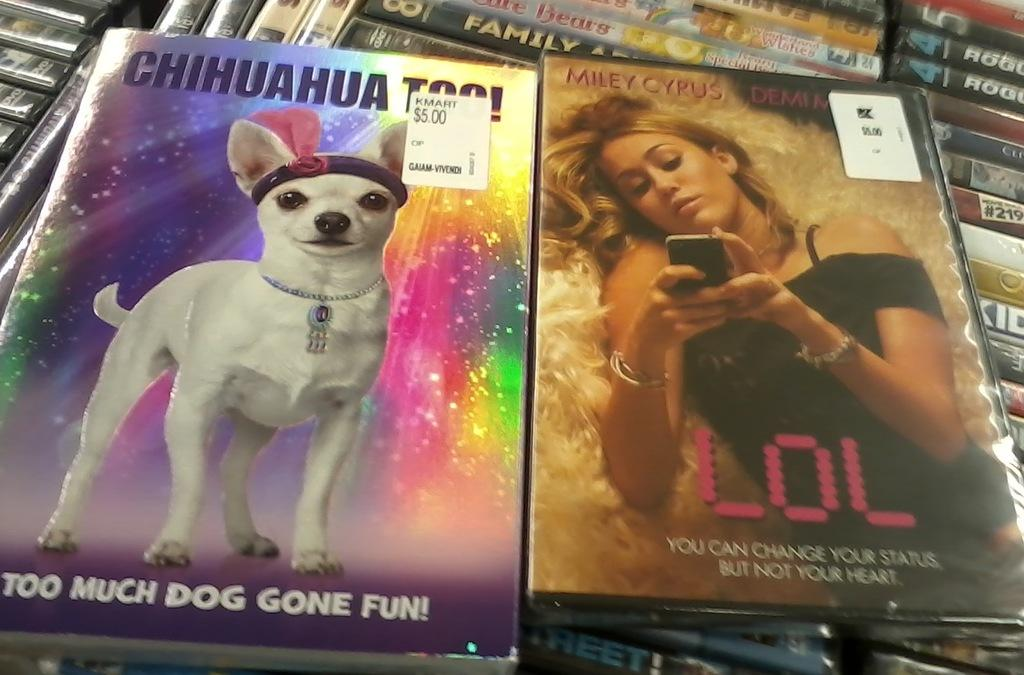What can be found in the image that is typically used for decoration or personalization? There are stickers in the image. What type of printed materials are present in the image? There are posters in the image. What subjects are depicted on the posters? On the posters, there is a dog, a woman, a mobile, and some text. What items can be seen in the background of the image? There are books in the background of the image. What type of collar is the snail wearing in the image? There is no snail present in the image, and therefore no collar can be observed. What idea does the woman on the poster have for the dog? The image does not provide any information about the woman's idea for the dog, as it only shows the presence of a dog and a woman on the poster. 